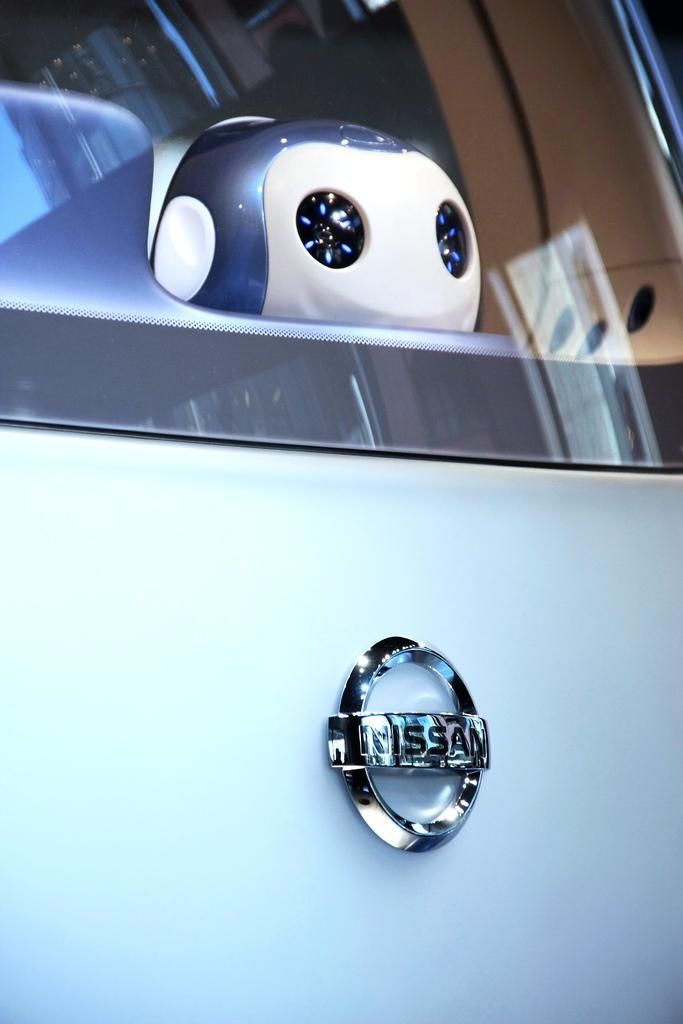What is the main object in the image? There is a car glass in the image. Is there any branding or identification visible in the image? Yes, there is a logo visible in the image. What can be seen through the car glass? There is a doll visible through the car glass. What type of needle is being used to sew the doll's clothing in the image? There is no needle or doll's clothing present in the image; it only features a car glass with a doll visible through it. 